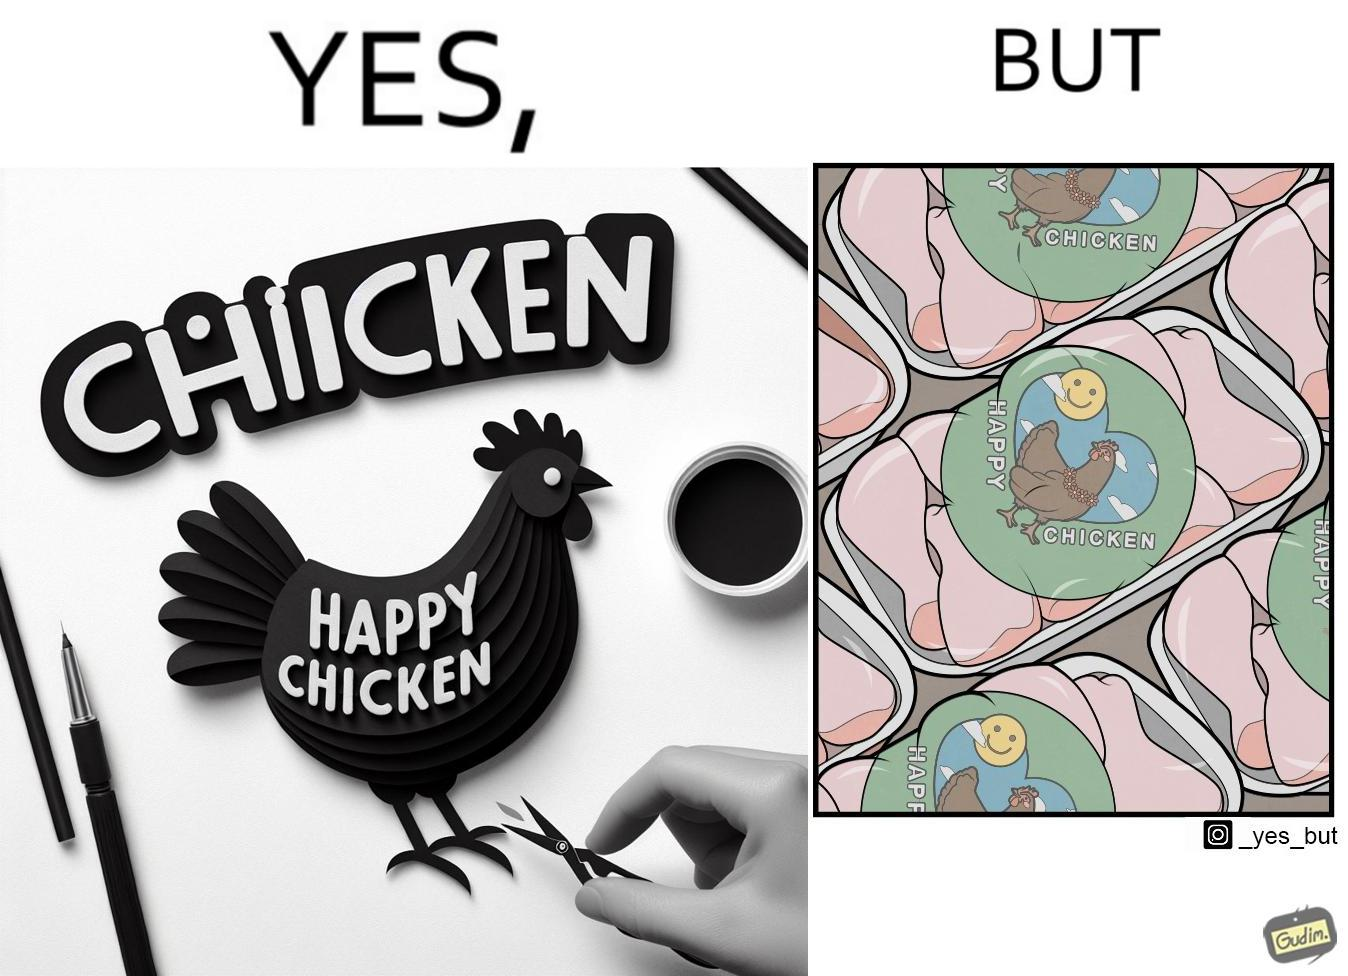Is there satirical content in this image? Yes, this image is satirical. 